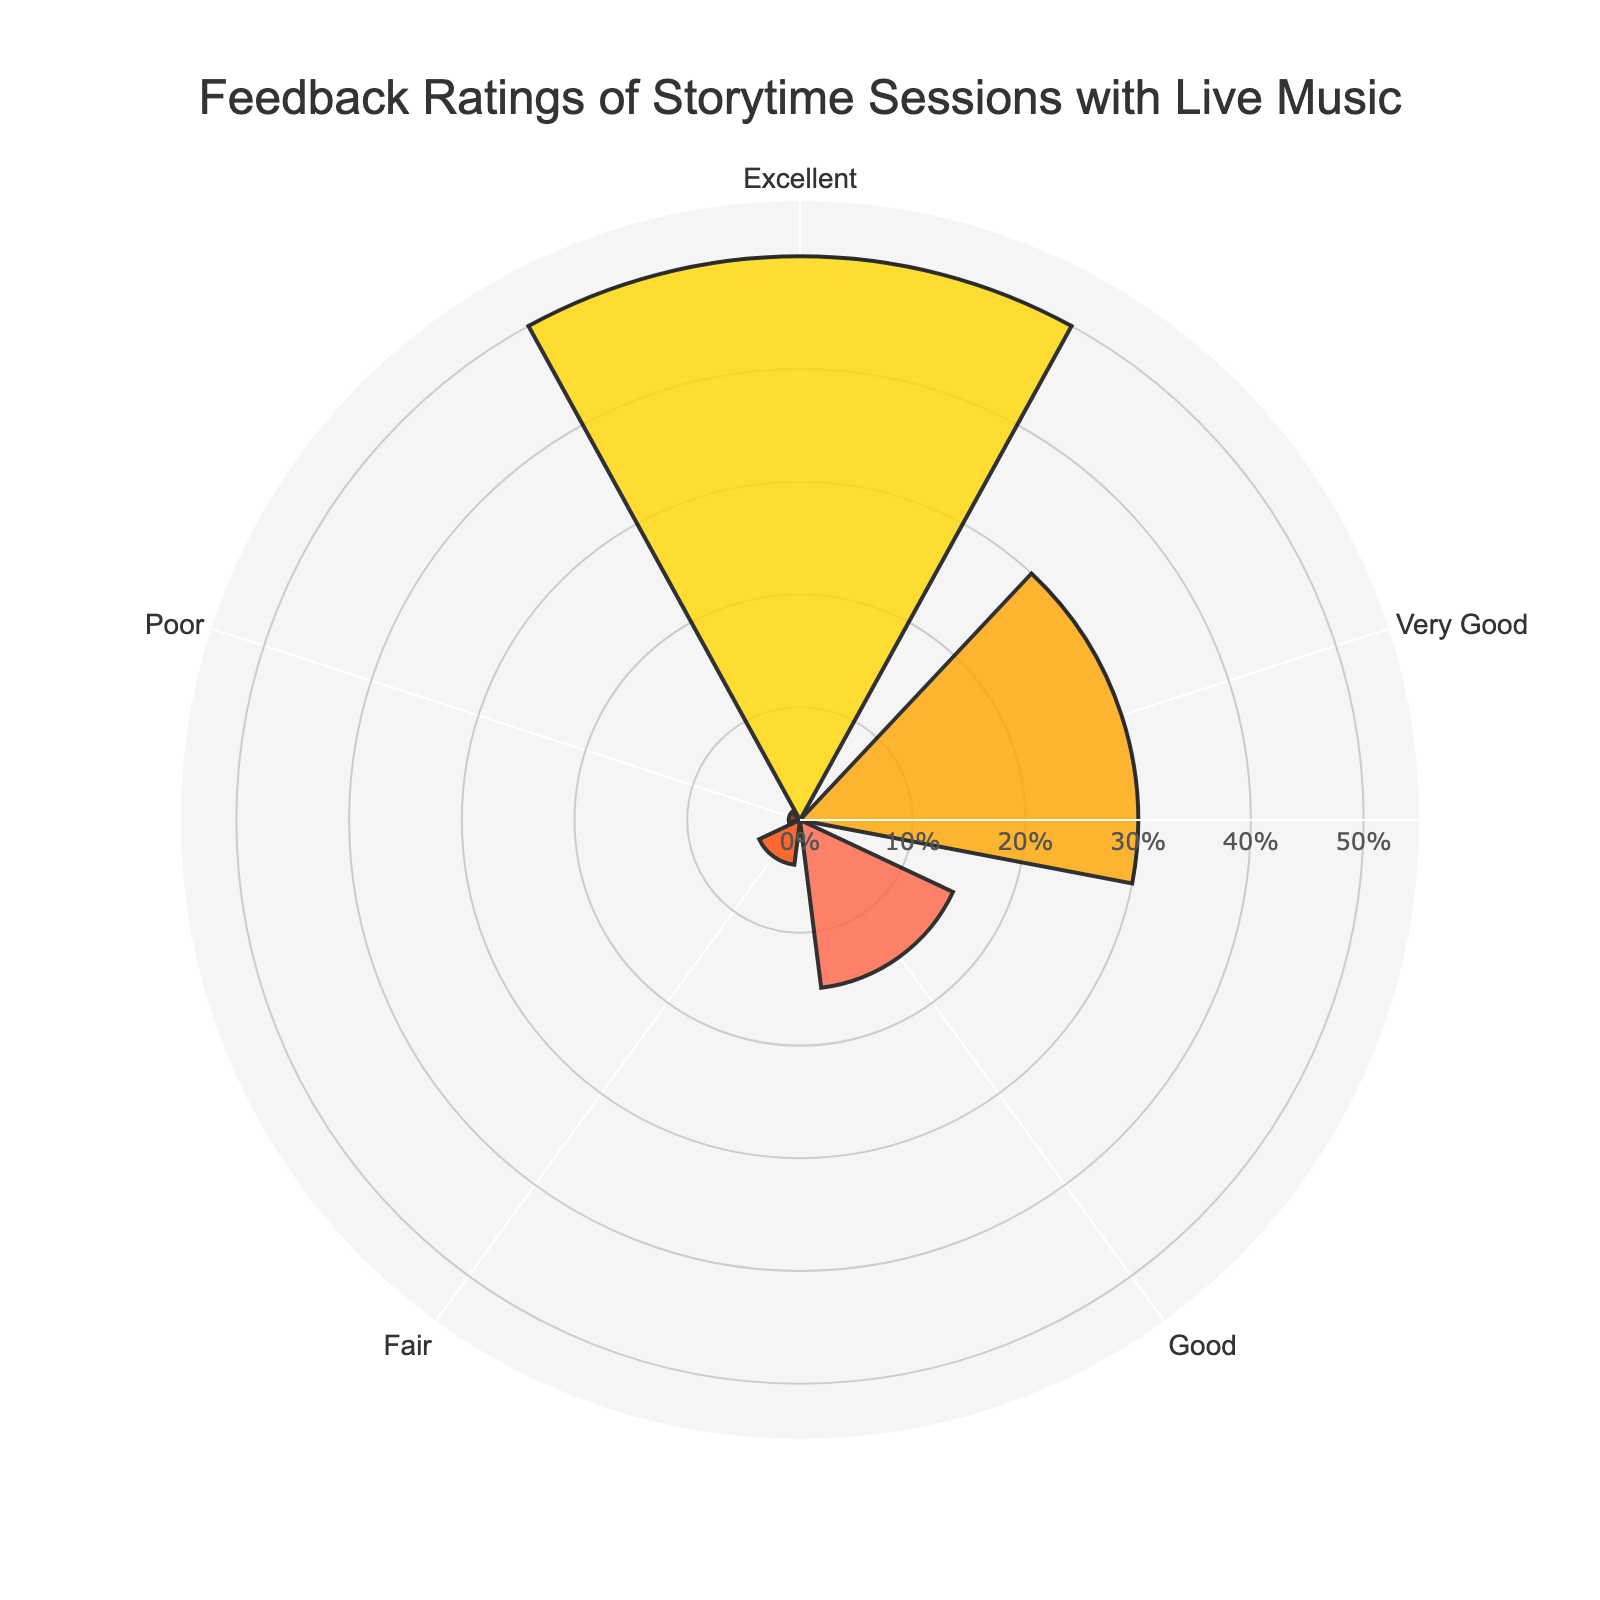What is the title of the chart? The title of the chart is written at the top and it reads "Feedback Ratings of Storytime Sessions with Live Music".
Answer: Feedback Ratings of Storytime Sessions with Live Music What category has the highest percentage of feedback? The highest percentage is represented by the bar extending the furthest from the center, labeled "Excellent".
Answer: Excellent How many categories are displayed in the chart? Count the distinct labels in the angular axis of the chart; they are "Excellent", "Very Good", "Good", "Fair", and "Poor".
Answer: 5 What percentage of feedback is rated as 'Fair'? The "Fair" bar has a percentage label just outside it, which reads "5.2%".
Answer: 5.2% Which rating category has the smallest percentage of feedback? Identify the bar that is closest to the center of the chart, labeled "Poor".
Answer: Poor What is the combined percentage of feedback rated as 'Excellent' and 'Very Good'? The 'Excellent' category has 65.8% and the 'Very Good' category has 39.5%; add them together: 65.8% + 39.5% = 105.3%.
Answer: 105.3% Which category has more feedback, 'Good' or 'Fair'? By comparing the lengths of corresponding bars, 'Good' has a longer bar than 'Fair', indicating a higher percentage.
Answer: Good What percentage of feedback is rated as 'Poor'? The "Poor" bar has a percentage label near it, which reads "1.3%".
Answer: 1.3% How does the percentage of 'Very Good' compare to 'Good'? 'Very Good' has a longer bar than 'Good', indicating a higher percentage.
Answer: Higher What is the median rating category based on percentage? List the percentages in order: [1.3%, 5.2%, 19.7%, 39.5%, 65.8%]; the middle value is 19.7%, corresponding to 'Good'.
Answer: Good 